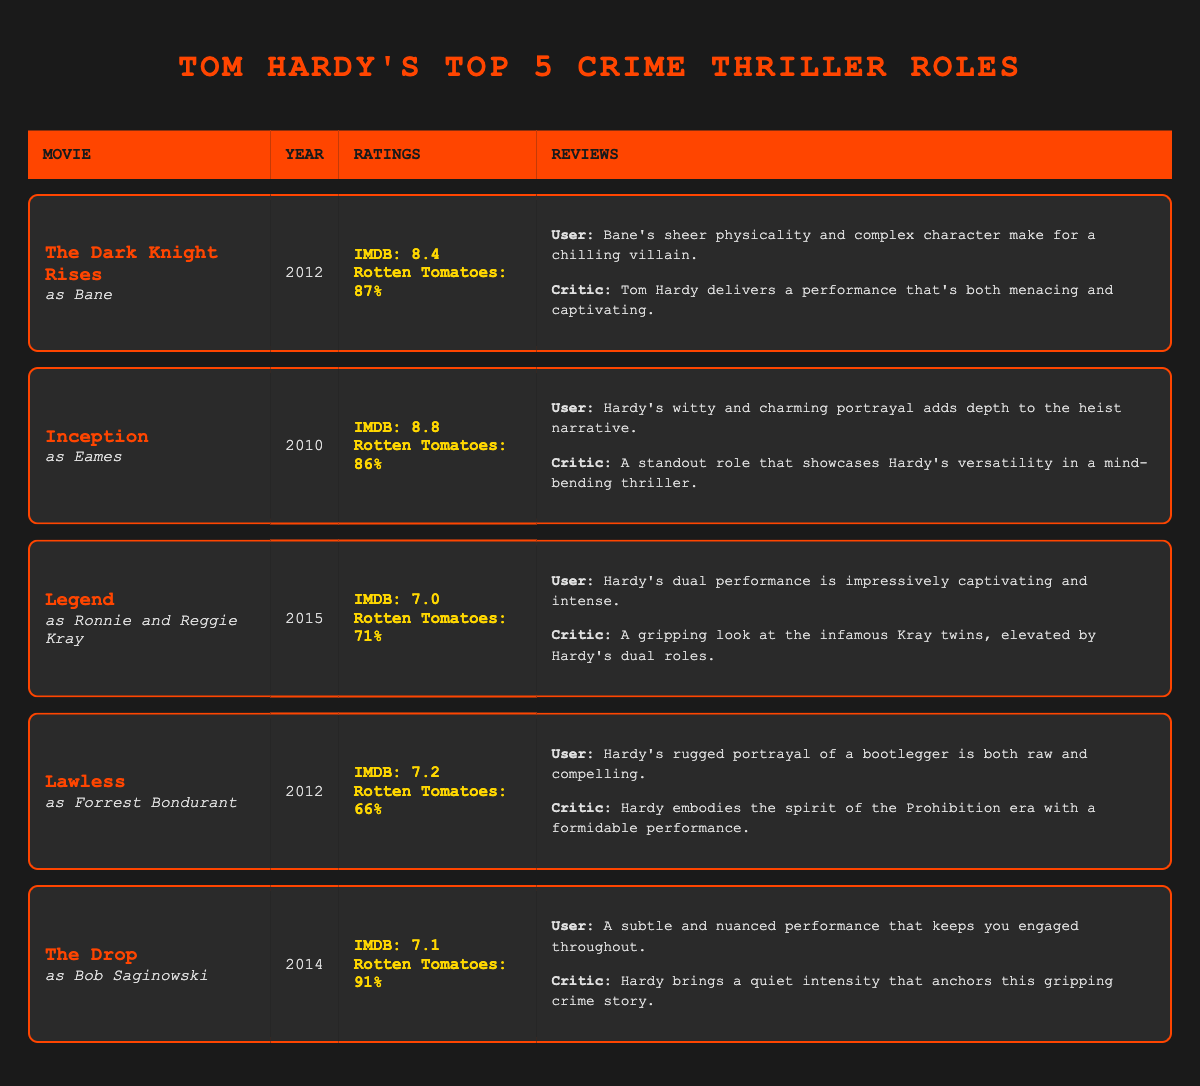What is the Rotten Tomatoes score for "The Drop"? The Rotten Tomatoes score for "The Drop" is located in the fourth row under the "Ratings" column. It shows "Rotten Tomatoes: 91%".
Answer: 91% Which movie features Tom Hardy as the character Bane? The character Bane is listed in the first row, under the movie title "The Dark Knight Rises" in the "Movie" column.
Answer: The Dark Knight Rises What is the average IMDB rating of the five films? To find the average IMDB rating, sum all the IMDB ratings: 8.4 + 8.8 + 7.0 + 7.2 + 7.1 = 38.5. There are 5 films, so the average is 38.5 / 5 = 7.7.
Answer: 7.7 Did "Legend" receive a Rotten Tomatoes score above 70%? The score for "Legend" is 71% in the "Ratings" column. Since 71% is above 70%, the answer is yes.
Answer: Yes Which character did Tom Hardy portray in "Lawless"? In the "Movie" column for "Lawless", it specifies that Hardy plays the character "Forrest Bondurant" in the corresponding row.
Answer: Forrest Bondurant What is the difference in IMDB ratings between "Inception" and "Lawless"? The IMDB rating for "Inception" is 8.8 and for "Lawless" it is 7.2. To find the difference, subtract: 8.8 - 7.2 = 1.6.
Answer: 1.6 In which year was "The Drop" released? The year for "The Drop" is found in the fourth row under the "Year" column, which shows it was released in 2014.
Answer: 2014 Which two films have the lowest IMDB ratings, and what are their scores? The films with the two lowest IMDB ratings are "Legend" at 7.0 and "The Drop" at 7.1. Both can be found in their respective rows under the "IMDB Rating" column.
Answer: Legend: 7.0, The Drop: 7.1 Is it true that Tom Hardy's performance in "Inception" was praised for showcasing his versatility? The critic review for "Inception" states that "A standout role that showcases Hardy's versatility in a mind-bending thriller." Therefore, it confirms the statement as true.
Answer: True 